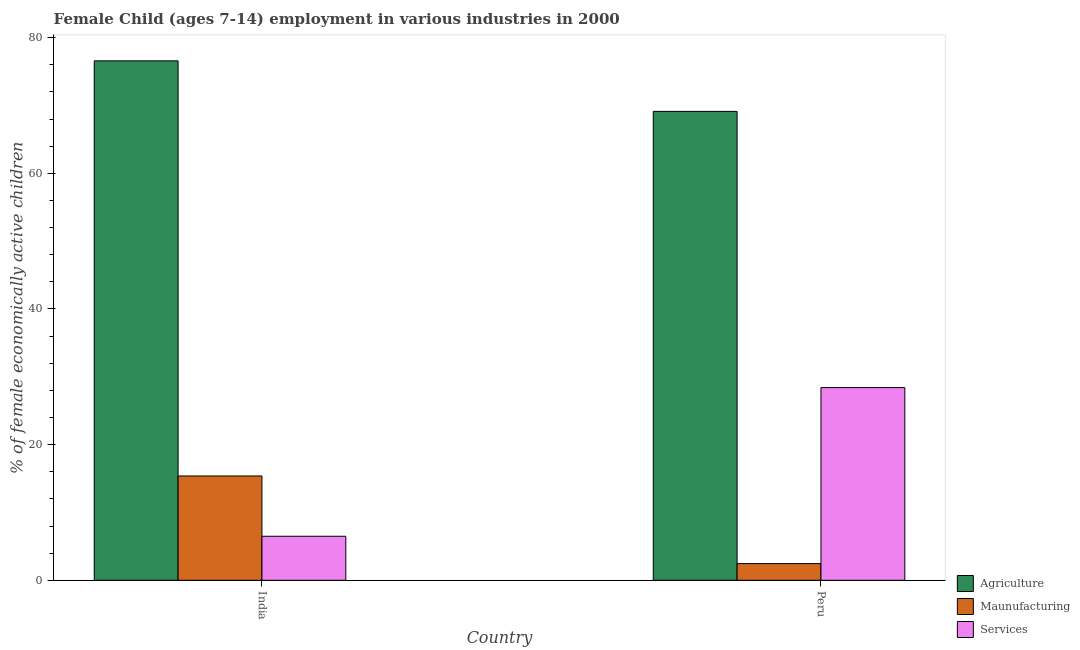How many different coloured bars are there?
Provide a succinct answer. 3. Are the number of bars on each tick of the X-axis equal?
Make the answer very short. Yes. How many bars are there on the 1st tick from the right?
Offer a terse response. 3. In how many cases, is the number of bars for a given country not equal to the number of legend labels?
Your answer should be compact. 0. What is the percentage of economically active children in services in Peru?
Keep it short and to the point. 28.41. Across all countries, what is the maximum percentage of economically active children in manufacturing?
Keep it short and to the point. 15.38. Across all countries, what is the minimum percentage of economically active children in services?
Offer a terse response. 6.49. In which country was the percentage of economically active children in services minimum?
Offer a very short reply. India. What is the total percentage of economically active children in agriculture in the graph?
Provide a succinct answer. 145.71. What is the difference between the percentage of economically active children in manufacturing in India and that in Peru?
Give a very brief answer. 12.92. What is the difference between the percentage of economically active children in agriculture in Peru and the percentage of economically active children in manufacturing in India?
Your answer should be very brief. 53.75. What is the average percentage of economically active children in agriculture per country?
Your answer should be compact. 72.85. What is the difference between the percentage of economically active children in services and percentage of economically active children in agriculture in India?
Provide a short and direct response. -70.09. What is the ratio of the percentage of economically active children in agriculture in India to that in Peru?
Keep it short and to the point. 1.11. Is the percentage of economically active children in services in India less than that in Peru?
Your response must be concise. Yes. In how many countries, is the percentage of economically active children in agriculture greater than the average percentage of economically active children in agriculture taken over all countries?
Make the answer very short. 1. What does the 3rd bar from the left in Peru represents?
Your answer should be very brief. Services. What does the 2nd bar from the right in India represents?
Your answer should be compact. Maunufacturing. Are all the bars in the graph horizontal?
Your response must be concise. No. How many countries are there in the graph?
Keep it short and to the point. 2. What is the title of the graph?
Your response must be concise. Female Child (ages 7-14) employment in various industries in 2000. Does "Tertiary" appear as one of the legend labels in the graph?
Provide a short and direct response. No. What is the label or title of the Y-axis?
Your answer should be very brief. % of female economically active children. What is the % of female economically active children of Agriculture in India?
Your response must be concise. 76.58. What is the % of female economically active children in Maunufacturing in India?
Offer a terse response. 15.38. What is the % of female economically active children of Services in India?
Give a very brief answer. 6.49. What is the % of female economically active children in Agriculture in Peru?
Give a very brief answer. 69.13. What is the % of female economically active children of Maunufacturing in Peru?
Provide a short and direct response. 2.46. What is the % of female economically active children of Services in Peru?
Provide a succinct answer. 28.41. Across all countries, what is the maximum % of female economically active children in Agriculture?
Offer a very short reply. 76.58. Across all countries, what is the maximum % of female economically active children of Maunufacturing?
Offer a very short reply. 15.38. Across all countries, what is the maximum % of female economically active children of Services?
Offer a very short reply. 28.41. Across all countries, what is the minimum % of female economically active children in Agriculture?
Ensure brevity in your answer.  69.13. Across all countries, what is the minimum % of female economically active children in Maunufacturing?
Your answer should be compact. 2.46. Across all countries, what is the minimum % of female economically active children in Services?
Provide a succinct answer. 6.49. What is the total % of female economically active children of Agriculture in the graph?
Your response must be concise. 145.71. What is the total % of female economically active children of Maunufacturing in the graph?
Give a very brief answer. 17.84. What is the total % of female economically active children of Services in the graph?
Give a very brief answer. 34.9. What is the difference between the % of female economically active children in Agriculture in India and that in Peru?
Ensure brevity in your answer.  7.45. What is the difference between the % of female economically active children in Maunufacturing in India and that in Peru?
Offer a very short reply. 12.92. What is the difference between the % of female economically active children in Services in India and that in Peru?
Your response must be concise. -21.92. What is the difference between the % of female economically active children in Agriculture in India and the % of female economically active children in Maunufacturing in Peru?
Give a very brief answer. 74.12. What is the difference between the % of female economically active children of Agriculture in India and the % of female economically active children of Services in Peru?
Ensure brevity in your answer.  48.17. What is the difference between the % of female economically active children of Maunufacturing in India and the % of female economically active children of Services in Peru?
Your answer should be very brief. -13.03. What is the average % of female economically active children of Agriculture per country?
Keep it short and to the point. 72.86. What is the average % of female economically active children in Maunufacturing per country?
Provide a short and direct response. 8.92. What is the average % of female economically active children in Services per country?
Your response must be concise. 17.45. What is the difference between the % of female economically active children of Agriculture and % of female economically active children of Maunufacturing in India?
Ensure brevity in your answer.  61.2. What is the difference between the % of female economically active children of Agriculture and % of female economically active children of Services in India?
Your response must be concise. 70.09. What is the difference between the % of female economically active children in Maunufacturing and % of female economically active children in Services in India?
Your answer should be very brief. 8.89. What is the difference between the % of female economically active children in Agriculture and % of female economically active children in Maunufacturing in Peru?
Ensure brevity in your answer.  66.67. What is the difference between the % of female economically active children in Agriculture and % of female economically active children in Services in Peru?
Your answer should be very brief. 40.72. What is the difference between the % of female economically active children in Maunufacturing and % of female economically active children in Services in Peru?
Keep it short and to the point. -25.95. What is the ratio of the % of female economically active children of Agriculture in India to that in Peru?
Ensure brevity in your answer.  1.11. What is the ratio of the % of female economically active children of Maunufacturing in India to that in Peru?
Make the answer very short. 6.25. What is the ratio of the % of female economically active children in Services in India to that in Peru?
Provide a succinct answer. 0.23. What is the difference between the highest and the second highest % of female economically active children in Agriculture?
Give a very brief answer. 7.45. What is the difference between the highest and the second highest % of female economically active children in Maunufacturing?
Make the answer very short. 12.92. What is the difference between the highest and the second highest % of female economically active children of Services?
Provide a short and direct response. 21.92. What is the difference between the highest and the lowest % of female economically active children in Agriculture?
Your response must be concise. 7.45. What is the difference between the highest and the lowest % of female economically active children of Maunufacturing?
Make the answer very short. 12.92. What is the difference between the highest and the lowest % of female economically active children in Services?
Offer a terse response. 21.92. 